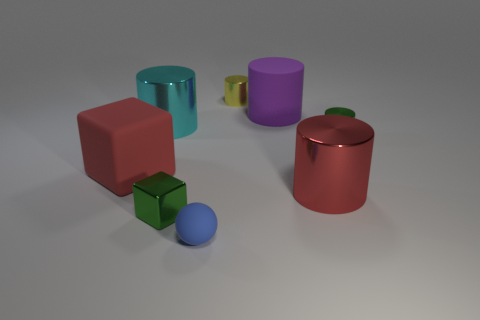Are there the same number of large things in front of the large red matte object and green objects?
Provide a short and direct response. No. There is a object that is the same color as the large cube; what is its size?
Make the answer very short. Large. Is there a ball that has the same material as the large cube?
Ensure brevity in your answer.  Yes. There is a green metal thing that is behind the small cube; does it have the same shape as the big red thing left of the small blue sphere?
Your response must be concise. No. Is there a big brown rubber cylinder?
Keep it short and to the point. No. There is a shiny block that is the same size as the blue thing; what is its color?
Your response must be concise. Green. What number of small blue objects have the same shape as the red shiny thing?
Provide a short and direct response. 0. Are the big cyan cylinder that is behind the blue rubber thing and the sphere made of the same material?
Your answer should be very brief. No. How many cylinders are either large purple metallic things or yellow things?
Your answer should be compact. 1. What is the shape of the green object that is to the left of the rubber object that is behind the red cube that is left of the red shiny cylinder?
Keep it short and to the point. Cube. 